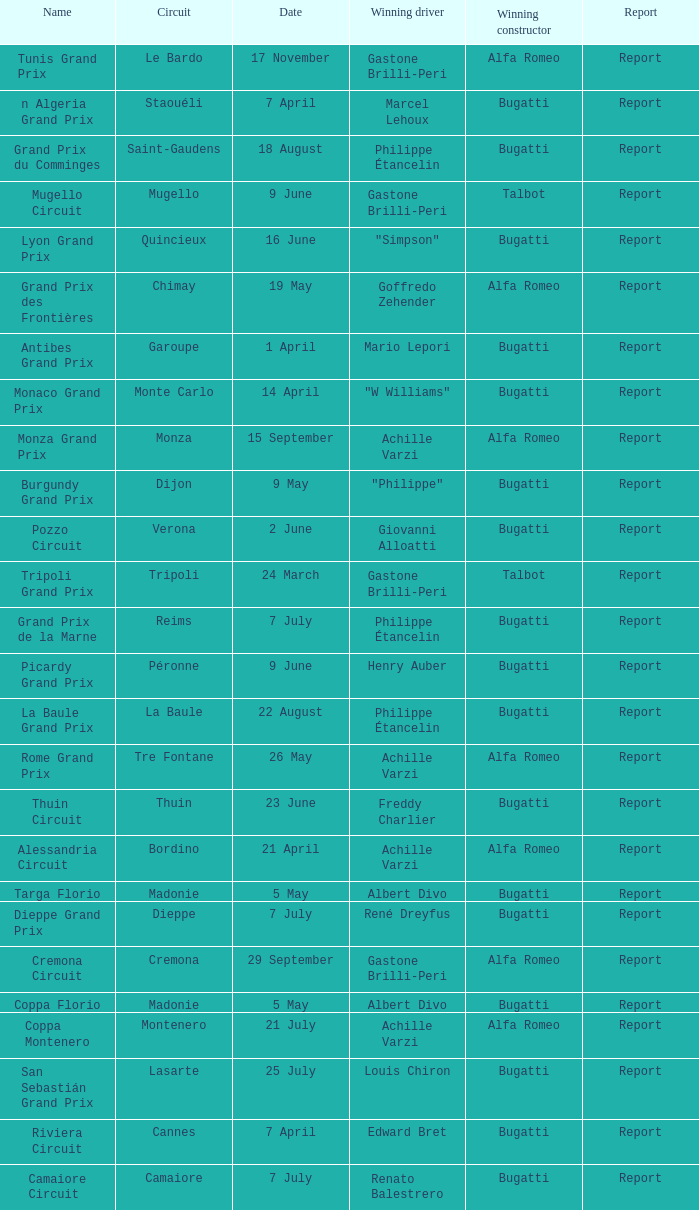What Winning driver has a Name of mugello circuit? Gastone Brilli-Peri. 